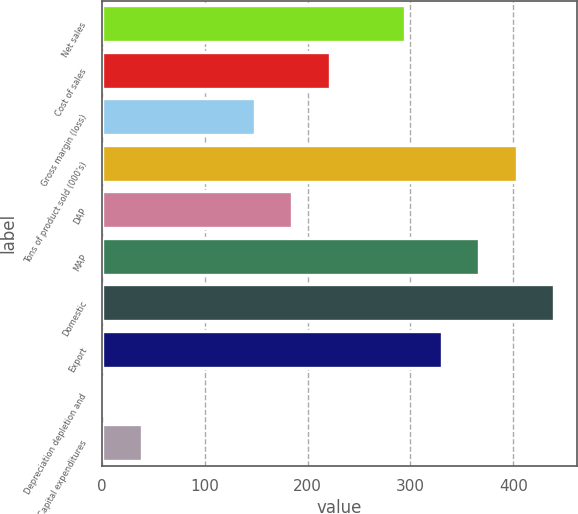<chart> <loc_0><loc_0><loc_500><loc_500><bar_chart><fcel>Net sales<fcel>Cost of sales<fcel>Gross margin (loss)<fcel>Tons of product sold (000's)<fcel>DAP<fcel>MAP<fcel>Domestic<fcel>Export<fcel>Depreciation depletion and<fcel>Capital expenditures<nl><fcel>294.22<fcel>221.44<fcel>148.66<fcel>403.39<fcel>185.05<fcel>367<fcel>439.78<fcel>330.61<fcel>3.1<fcel>39.49<nl></chart> 